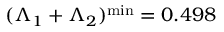Convert formula to latex. <formula><loc_0><loc_0><loc_500><loc_500>( \Lambda _ { 1 } + \Lambda _ { 2 } ) ^ { \min } = 0 . 4 9 8</formula> 